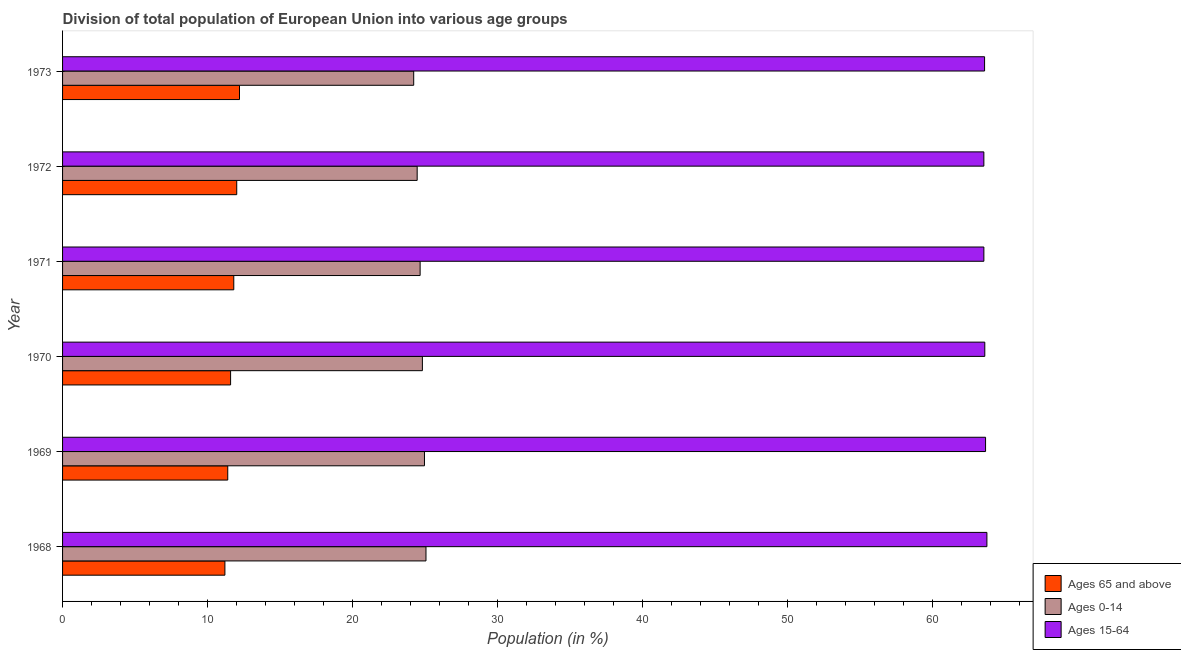How many different coloured bars are there?
Make the answer very short. 3. How many bars are there on the 2nd tick from the top?
Your answer should be very brief. 3. What is the label of the 6th group of bars from the top?
Give a very brief answer. 1968. In how many cases, is the number of bars for a given year not equal to the number of legend labels?
Give a very brief answer. 0. What is the percentage of population within the age-group 0-14 in 1970?
Offer a terse response. 24.81. Across all years, what is the maximum percentage of population within the age-group of 65 and above?
Your response must be concise. 12.2. Across all years, what is the minimum percentage of population within the age-group 15-64?
Offer a very short reply. 63.53. In which year was the percentage of population within the age-group of 65 and above minimum?
Keep it short and to the point. 1968. What is the total percentage of population within the age-group 0-14 in the graph?
Offer a terse response. 148.16. What is the difference between the percentage of population within the age-group 0-14 in 1970 and that in 1972?
Provide a succinct answer. 0.36. What is the difference between the percentage of population within the age-group 15-64 in 1968 and the percentage of population within the age-group of 65 and above in 1971?
Provide a succinct answer. 51.94. What is the average percentage of population within the age-group of 65 and above per year?
Your answer should be compact. 11.7. In the year 1970, what is the difference between the percentage of population within the age-group 15-64 and percentage of population within the age-group 0-14?
Keep it short and to the point. 38.78. What is the ratio of the percentage of population within the age-group 0-14 in 1968 to that in 1973?
Ensure brevity in your answer.  1.03. What is the difference between the highest and the second highest percentage of population within the age-group 0-14?
Offer a very short reply. 0.1. What does the 2nd bar from the top in 1973 represents?
Ensure brevity in your answer.  Ages 0-14. What does the 1st bar from the bottom in 1971 represents?
Keep it short and to the point. Ages 65 and above. Are all the bars in the graph horizontal?
Keep it short and to the point. Yes. What is the difference between two consecutive major ticks on the X-axis?
Provide a short and direct response. 10. Does the graph contain grids?
Make the answer very short. No. Where does the legend appear in the graph?
Ensure brevity in your answer.  Bottom right. How are the legend labels stacked?
Your answer should be compact. Vertical. What is the title of the graph?
Offer a very short reply. Division of total population of European Union into various age groups
. What is the label or title of the X-axis?
Ensure brevity in your answer.  Population (in %). What is the Population (in %) in Ages 65 and above in 1968?
Keep it short and to the point. 11.2. What is the Population (in %) of Ages 0-14 in 1968?
Give a very brief answer. 25.06. What is the Population (in %) in Ages 15-64 in 1968?
Give a very brief answer. 63.74. What is the Population (in %) of Ages 65 and above in 1969?
Ensure brevity in your answer.  11.39. What is the Population (in %) in Ages 0-14 in 1969?
Your answer should be very brief. 24.96. What is the Population (in %) of Ages 15-64 in 1969?
Keep it short and to the point. 63.65. What is the Population (in %) in Ages 65 and above in 1970?
Make the answer very short. 11.59. What is the Population (in %) of Ages 0-14 in 1970?
Give a very brief answer. 24.81. What is the Population (in %) of Ages 15-64 in 1970?
Provide a short and direct response. 63.6. What is the Population (in %) of Ages 65 and above in 1971?
Provide a short and direct response. 11.81. What is the Population (in %) in Ages 0-14 in 1971?
Make the answer very short. 24.66. What is the Population (in %) in Ages 15-64 in 1971?
Offer a terse response. 63.53. What is the Population (in %) in Ages 65 and above in 1972?
Offer a terse response. 12.01. What is the Population (in %) of Ages 0-14 in 1972?
Make the answer very short. 24.45. What is the Population (in %) of Ages 15-64 in 1972?
Offer a very short reply. 63.53. What is the Population (in %) of Ages 65 and above in 1973?
Make the answer very short. 12.2. What is the Population (in %) of Ages 0-14 in 1973?
Give a very brief answer. 24.21. What is the Population (in %) of Ages 15-64 in 1973?
Provide a short and direct response. 63.58. Across all years, what is the maximum Population (in %) in Ages 65 and above?
Give a very brief answer. 12.2. Across all years, what is the maximum Population (in %) in Ages 0-14?
Ensure brevity in your answer.  25.06. Across all years, what is the maximum Population (in %) of Ages 15-64?
Your response must be concise. 63.74. Across all years, what is the minimum Population (in %) in Ages 65 and above?
Your answer should be compact. 11.2. Across all years, what is the minimum Population (in %) of Ages 0-14?
Your answer should be very brief. 24.21. Across all years, what is the minimum Population (in %) in Ages 15-64?
Your answer should be very brief. 63.53. What is the total Population (in %) in Ages 65 and above in the graph?
Provide a succinct answer. 70.19. What is the total Population (in %) of Ages 0-14 in the graph?
Offer a terse response. 148.16. What is the total Population (in %) of Ages 15-64 in the graph?
Give a very brief answer. 381.65. What is the difference between the Population (in %) in Ages 65 and above in 1968 and that in 1969?
Make the answer very short. -0.2. What is the difference between the Population (in %) in Ages 0-14 in 1968 and that in 1969?
Offer a terse response. 0.1. What is the difference between the Population (in %) of Ages 15-64 in 1968 and that in 1969?
Provide a succinct answer. 0.09. What is the difference between the Population (in %) of Ages 65 and above in 1968 and that in 1970?
Give a very brief answer. -0.39. What is the difference between the Population (in %) of Ages 0-14 in 1968 and that in 1970?
Keep it short and to the point. 0.25. What is the difference between the Population (in %) of Ages 15-64 in 1968 and that in 1970?
Make the answer very short. 0.14. What is the difference between the Population (in %) in Ages 65 and above in 1968 and that in 1971?
Provide a short and direct response. -0.61. What is the difference between the Population (in %) in Ages 0-14 in 1968 and that in 1971?
Give a very brief answer. 0.4. What is the difference between the Population (in %) of Ages 15-64 in 1968 and that in 1971?
Keep it short and to the point. 0.21. What is the difference between the Population (in %) in Ages 65 and above in 1968 and that in 1972?
Make the answer very short. -0.82. What is the difference between the Population (in %) in Ages 0-14 in 1968 and that in 1972?
Make the answer very short. 0.61. What is the difference between the Population (in %) in Ages 15-64 in 1968 and that in 1972?
Your answer should be very brief. 0.21. What is the difference between the Population (in %) in Ages 65 and above in 1968 and that in 1973?
Give a very brief answer. -1.01. What is the difference between the Population (in %) in Ages 0-14 in 1968 and that in 1973?
Make the answer very short. 0.85. What is the difference between the Population (in %) of Ages 15-64 in 1968 and that in 1973?
Provide a short and direct response. 0.16. What is the difference between the Population (in %) in Ages 65 and above in 1969 and that in 1970?
Offer a very short reply. -0.2. What is the difference between the Population (in %) in Ages 0-14 in 1969 and that in 1970?
Your answer should be very brief. 0.14. What is the difference between the Population (in %) of Ages 15-64 in 1969 and that in 1970?
Your response must be concise. 0.05. What is the difference between the Population (in %) of Ages 65 and above in 1969 and that in 1971?
Your answer should be very brief. -0.42. What is the difference between the Population (in %) in Ages 0-14 in 1969 and that in 1971?
Keep it short and to the point. 0.3. What is the difference between the Population (in %) of Ages 15-64 in 1969 and that in 1971?
Give a very brief answer. 0.12. What is the difference between the Population (in %) in Ages 65 and above in 1969 and that in 1972?
Keep it short and to the point. -0.62. What is the difference between the Population (in %) in Ages 0-14 in 1969 and that in 1972?
Ensure brevity in your answer.  0.5. What is the difference between the Population (in %) in Ages 15-64 in 1969 and that in 1972?
Your response must be concise. 0.12. What is the difference between the Population (in %) of Ages 65 and above in 1969 and that in 1973?
Offer a very short reply. -0.81. What is the difference between the Population (in %) in Ages 0-14 in 1969 and that in 1973?
Ensure brevity in your answer.  0.74. What is the difference between the Population (in %) of Ages 15-64 in 1969 and that in 1973?
Provide a succinct answer. 0.07. What is the difference between the Population (in %) of Ages 65 and above in 1970 and that in 1971?
Ensure brevity in your answer.  -0.22. What is the difference between the Population (in %) of Ages 0-14 in 1970 and that in 1971?
Make the answer very short. 0.16. What is the difference between the Population (in %) of Ages 15-64 in 1970 and that in 1971?
Your response must be concise. 0.06. What is the difference between the Population (in %) of Ages 65 and above in 1970 and that in 1972?
Make the answer very short. -0.42. What is the difference between the Population (in %) of Ages 0-14 in 1970 and that in 1972?
Ensure brevity in your answer.  0.36. What is the difference between the Population (in %) of Ages 15-64 in 1970 and that in 1972?
Give a very brief answer. 0.06. What is the difference between the Population (in %) of Ages 65 and above in 1970 and that in 1973?
Your answer should be very brief. -0.62. What is the difference between the Population (in %) of Ages 0-14 in 1970 and that in 1973?
Your answer should be compact. 0.6. What is the difference between the Population (in %) in Ages 15-64 in 1970 and that in 1973?
Make the answer very short. 0.02. What is the difference between the Population (in %) in Ages 65 and above in 1971 and that in 1972?
Make the answer very short. -0.2. What is the difference between the Population (in %) of Ages 0-14 in 1971 and that in 1972?
Offer a terse response. 0.2. What is the difference between the Population (in %) in Ages 15-64 in 1971 and that in 1972?
Offer a very short reply. 0. What is the difference between the Population (in %) of Ages 65 and above in 1971 and that in 1973?
Provide a short and direct response. -0.4. What is the difference between the Population (in %) in Ages 0-14 in 1971 and that in 1973?
Your answer should be compact. 0.44. What is the difference between the Population (in %) of Ages 15-64 in 1971 and that in 1973?
Your answer should be compact. -0.05. What is the difference between the Population (in %) in Ages 65 and above in 1972 and that in 1973?
Make the answer very short. -0.19. What is the difference between the Population (in %) in Ages 0-14 in 1972 and that in 1973?
Ensure brevity in your answer.  0.24. What is the difference between the Population (in %) of Ages 15-64 in 1972 and that in 1973?
Offer a very short reply. -0.05. What is the difference between the Population (in %) of Ages 65 and above in 1968 and the Population (in %) of Ages 0-14 in 1969?
Ensure brevity in your answer.  -13.76. What is the difference between the Population (in %) in Ages 65 and above in 1968 and the Population (in %) in Ages 15-64 in 1969?
Keep it short and to the point. -52.46. What is the difference between the Population (in %) in Ages 0-14 in 1968 and the Population (in %) in Ages 15-64 in 1969?
Offer a terse response. -38.59. What is the difference between the Population (in %) in Ages 65 and above in 1968 and the Population (in %) in Ages 0-14 in 1970?
Provide a short and direct response. -13.62. What is the difference between the Population (in %) of Ages 65 and above in 1968 and the Population (in %) of Ages 15-64 in 1970?
Your answer should be very brief. -52.4. What is the difference between the Population (in %) of Ages 0-14 in 1968 and the Population (in %) of Ages 15-64 in 1970?
Provide a short and direct response. -38.54. What is the difference between the Population (in %) of Ages 65 and above in 1968 and the Population (in %) of Ages 0-14 in 1971?
Your answer should be compact. -13.46. What is the difference between the Population (in %) in Ages 65 and above in 1968 and the Population (in %) in Ages 15-64 in 1971?
Give a very brief answer. -52.34. What is the difference between the Population (in %) in Ages 0-14 in 1968 and the Population (in %) in Ages 15-64 in 1971?
Keep it short and to the point. -38.47. What is the difference between the Population (in %) in Ages 65 and above in 1968 and the Population (in %) in Ages 0-14 in 1972?
Your answer should be compact. -13.26. What is the difference between the Population (in %) in Ages 65 and above in 1968 and the Population (in %) in Ages 15-64 in 1972?
Ensure brevity in your answer.  -52.34. What is the difference between the Population (in %) in Ages 0-14 in 1968 and the Population (in %) in Ages 15-64 in 1972?
Give a very brief answer. -38.47. What is the difference between the Population (in %) of Ages 65 and above in 1968 and the Population (in %) of Ages 0-14 in 1973?
Your answer should be very brief. -13.02. What is the difference between the Population (in %) in Ages 65 and above in 1968 and the Population (in %) in Ages 15-64 in 1973?
Offer a terse response. -52.39. What is the difference between the Population (in %) in Ages 0-14 in 1968 and the Population (in %) in Ages 15-64 in 1973?
Offer a terse response. -38.52. What is the difference between the Population (in %) in Ages 65 and above in 1969 and the Population (in %) in Ages 0-14 in 1970?
Keep it short and to the point. -13.42. What is the difference between the Population (in %) of Ages 65 and above in 1969 and the Population (in %) of Ages 15-64 in 1970?
Your answer should be compact. -52.21. What is the difference between the Population (in %) in Ages 0-14 in 1969 and the Population (in %) in Ages 15-64 in 1970?
Make the answer very short. -38.64. What is the difference between the Population (in %) of Ages 65 and above in 1969 and the Population (in %) of Ages 0-14 in 1971?
Ensure brevity in your answer.  -13.27. What is the difference between the Population (in %) of Ages 65 and above in 1969 and the Population (in %) of Ages 15-64 in 1971?
Provide a short and direct response. -52.14. What is the difference between the Population (in %) of Ages 0-14 in 1969 and the Population (in %) of Ages 15-64 in 1971?
Ensure brevity in your answer.  -38.58. What is the difference between the Population (in %) in Ages 65 and above in 1969 and the Population (in %) in Ages 0-14 in 1972?
Your answer should be compact. -13.06. What is the difference between the Population (in %) in Ages 65 and above in 1969 and the Population (in %) in Ages 15-64 in 1972?
Ensure brevity in your answer.  -52.14. What is the difference between the Population (in %) of Ages 0-14 in 1969 and the Population (in %) of Ages 15-64 in 1972?
Keep it short and to the point. -38.58. What is the difference between the Population (in %) of Ages 65 and above in 1969 and the Population (in %) of Ages 0-14 in 1973?
Provide a succinct answer. -12.82. What is the difference between the Population (in %) of Ages 65 and above in 1969 and the Population (in %) of Ages 15-64 in 1973?
Offer a very short reply. -52.19. What is the difference between the Population (in %) in Ages 0-14 in 1969 and the Population (in %) in Ages 15-64 in 1973?
Keep it short and to the point. -38.63. What is the difference between the Population (in %) of Ages 65 and above in 1970 and the Population (in %) of Ages 0-14 in 1971?
Offer a terse response. -13.07. What is the difference between the Population (in %) in Ages 65 and above in 1970 and the Population (in %) in Ages 15-64 in 1971?
Your answer should be compact. -51.95. What is the difference between the Population (in %) of Ages 0-14 in 1970 and the Population (in %) of Ages 15-64 in 1971?
Keep it short and to the point. -38.72. What is the difference between the Population (in %) in Ages 65 and above in 1970 and the Population (in %) in Ages 0-14 in 1972?
Offer a terse response. -12.87. What is the difference between the Population (in %) in Ages 65 and above in 1970 and the Population (in %) in Ages 15-64 in 1972?
Provide a short and direct response. -51.95. What is the difference between the Population (in %) in Ages 0-14 in 1970 and the Population (in %) in Ages 15-64 in 1972?
Ensure brevity in your answer.  -38.72. What is the difference between the Population (in %) of Ages 65 and above in 1970 and the Population (in %) of Ages 0-14 in 1973?
Offer a terse response. -12.63. What is the difference between the Population (in %) in Ages 65 and above in 1970 and the Population (in %) in Ages 15-64 in 1973?
Offer a terse response. -52. What is the difference between the Population (in %) in Ages 0-14 in 1970 and the Population (in %) in Ages 15-64 in 1973?
Offer a very short reply. -38.77. What is the difference between the Population (in %) of Ages 65 and above in 1971 and the Population (in %) of Ages 0-14 in 1972?
Your response must be concise. -12.65. What is the difference between the Population (in %) in Ages 65 and above in 1971 and the Population (in %) in Ages 15-64 in 1972?
Provide a succinct answer. -51.73. What is the difference between the Population (in %) of Ages 0-14 in 1971 and the Population (in %) of Ages 15-64 in 1972?
Keep it short and to the point. -38.88. What is the difference between the Population (in %) in Ages 65 and above in 1971 and the Population (in %) in Ages 0-14 in 1973?
Offer a terse response. -12.41. What is the difference between the Population (in %) in Ages 65 and above in 1971 and the Population (in %) in Ages 15-64 in 1973?
Offer a very short reply. -51.78. What is the difference between the Population (in %) in Ages 0-14 in 1971 and the Population (in %) in Ages 15-64 in 1973?
Provide a short and direct response. -38.92. What is the difference between the Population (in %) in Ages 65 and above in 1972 and the Population (in %) in Ages 0-14 in 1973?
Provide a succinct answer. -12.2. What is the difference between the Population (in %) of Ages 65 and above in 1972 and the Population (in %) of Ages 15-64 in 1973?
Your response must be concise. -51.57. What is the difference between the Population (in %) of Ages 0-14 in 1972 and the Population (in %) of Ages 15-64 in 1973?
Provide a succinct answer. -39.13. What is the average Population (in %) in Ages 65 and above per year?
Provide a succinct answer. 11.7. What is the average Population (in %) of Ages 0-14 per year?
Offer a very short reply. 24.69. What is the average Population (in %) of Ages 15-64 per year?
Provide a succinct answer. 63.61. In the year 1968, what is the difference between the Population (in %) of Ages 65 and above and Population (in %) of Ages 0-14?
Your response must be concise. -13.87. In the year 1968, what is the difference between the Population (in %) in Ages 65 and above and Population (in %) in Ages 15-64?
Provide a short and direct response. -52.55. In the year 1968, what is the difference between the Population (in %) in Ages 0-14 and Population (in %) in Ages 15-64?
Ensure brevity in your answer.  -38.68. In the year 1969, what is the difference between the Population (in %) of Ages 65 and above and Population (in %) of Ages 0-14?
Offer a terse response. -13.57. In the year 1969, what is the difference between the Population (in %) of Ages 65 and above and Population (in %) of Ages 15-64?
Ensure brevity in your answer.  -52.26. In the year 1969, what is the difference between the Population (in %) of Ages 0-14 and Population (in %) of Ages 15-64?
Your answer should be very brief. -38.69. In the year 1970, what is the difference between the Population (in %) in Ages 65 and above and Population (in %) in Ages 0-14?
Your response must be concise. -13.23. In the year 1970, what is the difference between the Population (in %) in Ages 65 and above and Population (in %) in Ages 15-64?
Keep it short and to the point. -52.01. In the year 1970, what is the difference between the Population (in %) of Ages 0-14 and Population (in %) of Ages 15-64?
Give a very brief answer. -38.78. In the year 1971, what is the difference between the Population (in %) of Ages 65 and above and Population (in %) of Ages 0-14?
Provide a succinct answer. -12.85. In the year 1971, what is the difference between the Population (in %) in Ages 65 and above and Population (in %) in Ages 15-64?
Make the answer very short. -51.73. In the year 1971, what is the difference between the Population (in %) of Ages 0-14 and Population (in %) of Ages 15-64?
Offer a terse response. -38.88. In the year 1972, what is the difference between the Population (in %) in Ages 65 and above and Population (in %) in Ages 0-14?
Your answer should be compact. -12.44. In the year 1972, what is the difference between the Population (in %) of Ages 65 and above and Population (in %) of Ages 15-64?
Your answer should be very brief. -51.52. In the year 1972, what is the difference between the Population (in %) of Ages 0-14 and Population (in %) of Ages 15-64?
Your answer should be compact. -39.08. In the year 1973, what is the difference between the Population (in %) of Ages 65 and above and Population (in %) of Ages 0-14?
Offer a terse response. -12.01. In the year 1973, what is the difference between the Population (in %) of Ages 65 and above and Population (in %) of Ages 15-64?
Offer a very short reply. -51.38. In the year 1973, what is the difference between the Population (in %) in Ages 0-14 and Population (in %) in Ages 15-64?
Make the answer very short. -39.37. What is the ratio of the Population (in %) of Ages 65 and above in 1968 to that in 1969?
Provide a succinct answer. 0.98. What is the ratio of the Population (in %) of Ages 65 and above in 1968 to that in 1970?
Offer a very short reply. 0.97. What is the ratio of the Population (in %) in Ages 15-64 in 1968 to that in 1970?
Keep it short and to the point. 1. What is the ratio of the Population (in %) of Ages 65 and above in 1968 to that in 1971?
Give a very brief answer. 0.95. What is the ratio of the Population (in %) of Ages 0-14 in 1968 to that in 1971?
Your response must be concise. 1.02. What is the ratio of the Population (in %) in Ages 65 and above in 1968 to that in 1972?
Keep it short and to the point. 0.93. What is the ratio of the Population (in %) in Ages 0-14 in 1968 to that in 1972?
Provide a succinct answer. 1.02. What is the ratio of the Population (in %) in Ages 65 and above in 1968 to that in 1973?
Give a very brief answer. 0.92. What is the ratio of the Population (in %) in Ages 0-14 in 1968 to that in 1973?
Provide a succinct answer. 1.03. What is the ratio of the Population (in %) of Ages 15-64 in 1968 to that in 1973?
Provide a short and direct response. 1. What is the ratio of the Population (in %) in Ages 65 and above in 1969 to that in 1970?
Offer a terse response. 0.98. What is the ratio of the Population (in %) in Ages 0-14 in 1969 to that in 1970?
Provide a short and direct response. 1.01. What is the ratio of the Population (in %) in Ages 15-64 in 1969 to that in 1970?
Provide a short and direct response. 1. What is the ratio of the Population (in %) in Ages 65 and above in 1969 to that in 1971?
Give a very brief answer. 0.96. What is the ratio of the Population (in %) in Ages 0-14 in 1969 to that in 1971?
Ensure brevity in your answer.  1.01. What is the ratio of the Population (in %) of Ages 15-64 in 1969 to that in 1971?
Provide a short and direct response. 1. What is the ratio of the Population (in %) in Ages 65 and above in 1969 to that in 1972?
Your answer should be compact. 0.95. What is the ratio of the Population (in %) in Ages 0-14 in 1969 to that in 1972?
Your answer should be compact. 1.02. What is the ratio of the Population (in %) of Ages 65 and above in 1969 to that in 1973?
Offer a very short reply. 0.93. What is the ratio of the Population (in %) of Ages 0-14 in 1969 to that in 1973?
Your answer should be very brief. 1.03. What is the ratio of the Population (in %) of Ages 15-64 in 1969 to that in 1973?
Ensure brevity in your answer.  1. What is the ratio of the Population (in %) in Ages 65 and above in 1970 to that in 1971?
Your response must be concise. 0.98. What is the ratio of the Population (in %) of Ages 0-14 in 1970 to that in 1971?
Offer a terse response. 1.01. What is the ratio of the Population (in %) in Ages 15-64 in 1970 to that in 1971?
Keep it short and to the point. 1. What is the ratio of the Population (in %) in Ages 65 and above in 1970 to that in 1972?
Your answer should be compact. 0.96. What is the ratio of the Population (in %) of Ages 0-14 in 1970 to that in 1972?
Keep it short and to the point. 1.01. What is the ratio of the Population (in %) in Ages 65 and above in 1970 to that in 1973?
Give a very brief answer. 0.95. What is the ratio of the Population (in %) of Ages 0-14 in 1970 to that in 1973?
Offer a very short reply. 1.02. What is the ratio of the Population (in %) of Ages 15-64 in 1970 to that in 1973?
Offer a terse response. 1. What is the ratio of the Population (in %) of Ages 0-14 in 1971 to that in 1972?
Offer a very short reply. 1.01. What is the ratio of the Population (in %) in Ages 65 and above in 1971 to that in 1973?
Offer a very short reply. 0.97. What is the ratio of the Population (in %) of Ages 0-14 in 1971 to that in 1973?
Provide a short and direct response. 1.02. What is the ratio of the Population (in %) of Ages 15-64 in 1971 to that in 1973?
Your answer should be compact. 1. What is the ratio of the Population (in %) of Ages 65 and above in 1972 to that in 1973?
Offer a terse response. 0.98. What is the ratio of the Population (in %) in Ages 0-14 in 1972 to that in 1973?
Keep it short and to the point. 1.01. What is the difference between the highest and the second highest Population (in %) of Ages 65 and above?
Your answer should be compact. 0.19. What is the difference between the highest and the second highest Population (in %) of Ages 0-14?
Provide a short and direct response. 0.1. What is the difference between the highest and the second highest Population (in %) of Ages 15-64?
Offer a very short reply. 0.09. What is the difference between the highest and the lowest Population (in %) of Ages 65 and above?
Your answer should be compact. 1.01. What is the difference between the highest and the lowest Population (in %) in Ages 0-14?
Your response must be concise. 0.85. What is the difference between the highest and the lowest Population (in %) in Ages 15-64?
Ensure brevity in your answer.  0.21. 